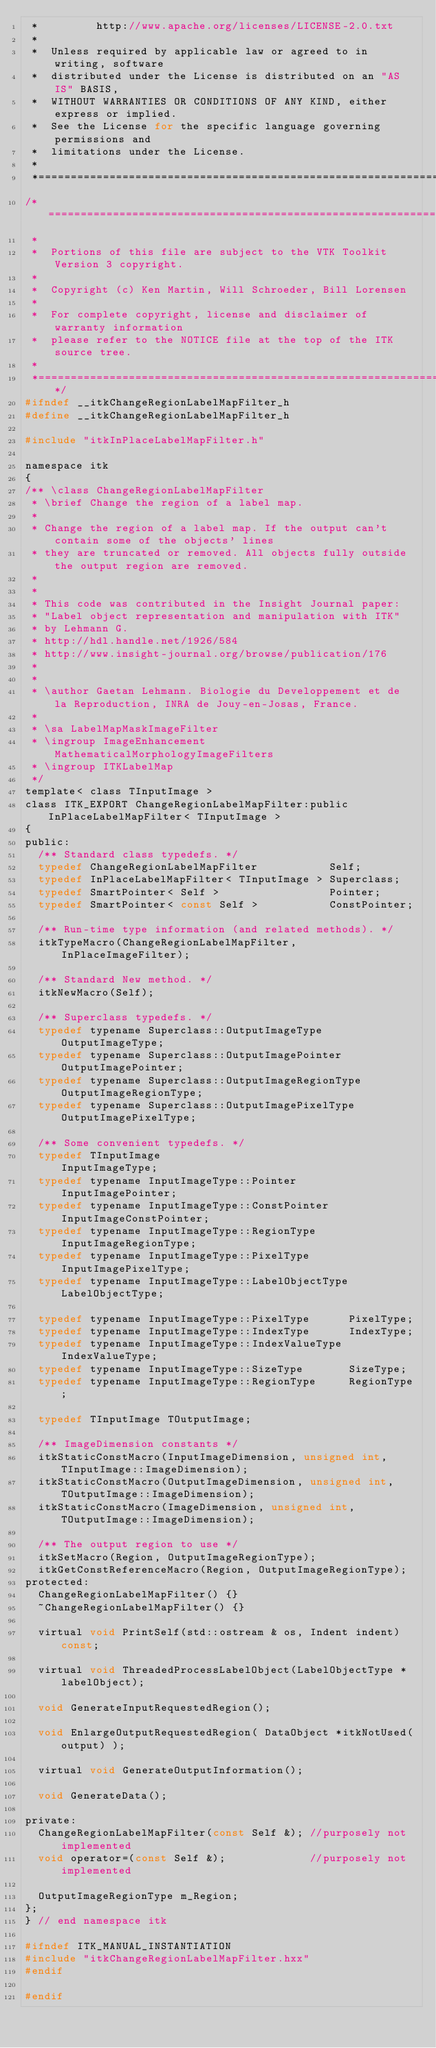<code> <loc_0><loc_0><loc_500><loc_500><_C_> *         http://www.apache.org/licenses/LICENSE-2.0.txt
 *
 *  Unless required by applicable law or agreed to in writing, software
 *  distributed under the License is distributed on an "AS IS" BASIS,
 *  WITHOUT WARRANTIES OR CONDITIONS OF ANY KIND, either express or implied.
 *  See the License for the specific language governing permissions and
 *  limitations under the License.
 *
 *=========================================================================*/
/*=========================================================================
 *
 *  Portions of this file are subject to the VTK Toolkit Version 3 copyright.
 *
 *  Copyright (c) Ken Martin, Will Schroeder, Bill Lorensen
 *
 *  For complete copyright, license and disclaimer of warranty information
 *  please refer to the NOTICE file at the top of the ITK source tree.
 *
 *=========================================================================*/
#ifndef __itkChangeRegionLabelMapFilter_h
#define __itkChangeRegionLabelMapFilter_h

#include "itkInPlaceLabelMapFilter.h"

namespace itk
{
/** \class ChangeRegionLabelMapFilter
 * \brief Change the region of a label map.
 *
 * Change the region of a label map. If the output can't contain some of the objects' lines
 * they are truncated or removed. All objects fully outside the output region are removed.
 *
 *
 * This code was contributed in the Insight Journal paper:
 * "Label object representation and manipulation with ITK"
 * by Lehmann G.
 * http://hdl.handle.net/1926/584
 * http://www.insight-journal.org/browse/publication/176
 *
 *
 * \author Gaetan Lehmann. Biologie du Developpement et de la Reproduction, INRA de Jouy-en-Josas, France.
 *
 * \sa LabelMapMaskImageFilter
 * \ingroup ImageEnhancement  MathematicalMorphologyImageFilters
 * \ingroup ITKLabelMap
 */
template< class TInputImage >
class ITK_EXPORT ChangeRegionLabelMapFilter:public InPlaceLabelMapFilter< TInputImage >
{
public:
  /** Standard class typedefs. */
  typedef ChangeRegionLabelMapFilter           Self;
  typedef InPlaceLabelMapFilter< TInputImage > Superclass;
  typedef SmartPointer< Self >                 Pointer;
  typedef SmartPointer< const Self >           ConstPointer;

  /** Run-time type information (and related methods). */
  itkTypeMacro(ChangeRegionLabelMapFilter, InPlaceImageFilter);

  /** Standard New method. */
  itkNewMacro(Self);

  /** Superclass typedefs. */
  typedef typename Superclass::OutputImageType       OutputImageType;
  typedef typename Superclass::OutputImagePointer    OutputImagePointer;
  typedef typename Superclass::OutputImageRegionType OutputImageRegionType;
  typedef typename Superclass::OutputImagePixelType  OutputImagePixelType;

  /** Some convenient typedefs. */
  typedef TInputImage                              InputImageType;
  typedef typename InputImageType::Pointer         InputImagePointer;
  typedef typename InputImageType::ConstPointer    InputImageConstPointer;
  typedef typename InputImageType::RegionType      InputImageRegionType;
  typedef typename InputImageType::PixelType       InputImagePixelType;
  typedef typename InputImageType::LabelObjectType LabelObjectType;

  typedef typename InputImageType::PixelType      PixelType;
  typedef typename InputImageType::IndexType      IndexType;
  typedef typename InputImageType::IndexValueType IndexValueType;
  typedef typename InputImageType::SizeType       SizeType;
  typedef typename InputImageType::RegionType     RegionType;

  typedef TInputImage TOutputImage;

  /** ImageDimension constants */
  itkStaticConstMacro(InputImageDimension, unsigned int, TInputImage::ImageDimension);
  itkStaticConstMacro(OutputImageDimension, unsigned int, TOutputImage::ImageDimension);
  itkStaticConstMacro(ImageDimension, unsigned int, TOutputImage::ImageDimension);

  /** The output region to use */
  itkSetMacro(Region, OutputImageRegionType);
  itkGetConstReferenceMacro(Region, OutputImageRegionType);
protected:
  ChangeRegionLabelMapFilter() {}
  ~ChangeRegionLabelMapFilter() {}

  virtual void PrintSelf(std::ostream & os, Indent indent) const;

  virtual void ThreadedProcessLabelObject(LabelObjectType *labelObject);

  void GenerateInputRequestedRegion();

  void EnlargeOutputRequestedRegion( DataObject *itkNotUsed(output) );

  virtual void GenerateOutputInformation();

  void GenerateData();

private:
  ChangeRegionLabelMapFilter(const Self &); //purposely not implemented
  void operator=(const Self &);             //purposely not implemented

  OutputImageRegionType m_Region;
};
} // end namespace itk

#ifndef ITK_MANUAL_INSTANTIATION
#include "itkChangeRegionLabelMapFilter.hxx"
#endif

#endif
</code> 